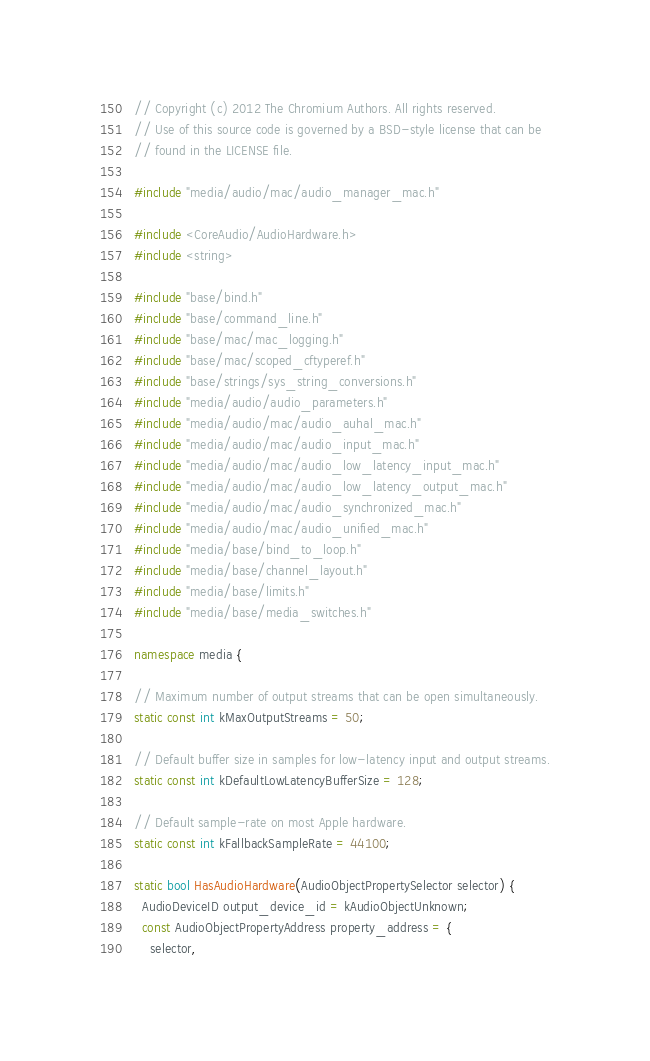Convert code to text. <code><loc_0><loc_0><loc_500><loc_500><_C++_>// Copyright (c) 2012 The Chromium Authors. All rights reserved.
// Use of this source code is governed by a BSD-style license that can be
// found in the LICENSE file.

#include "media/audio/mac/audio_manager_mac.h"

#include <CoreAudio/AudioHardware.h>
#include <string>

#include "base/bind.h"
#include "base/command_line.h"
#include "base/mac/mac_logging.h"
#include "base/mac/scoped_cftyperef.h"
#include "base/strings/sys_string_conversions.h"
#include "media/audio/audio_parameters.h"
#include "media/audio/mac/audio_auhal_mac.h"
#include "media/audio/mac/audio_input_mac.h"
#include "media/audio/mac/audio_low_latency_input_mac.h"
#include "media/audio/mac/audio_low_latency_output_mac.h"
#include "media/audio/mac/audio_synchronized_mac.h"
#include "media/audio/mac/audio_unified_mac.h"
#include "media/base/bind_to_loop.h"
#include "media/base/channel_layout.h"
#include "media/base/limits.h"
#include "media/base/media_switches.h"

namespace media {

// Maximum number of output streams that can be open simultaneously.
static const int kMaxOutputStreams = 50;

// Default buffer size in samples for low-latency input and output streams.
static const int kDefaultLowLatencyBufferSize = 128;

// Default sample-rate on most Apple hardware.
static const int kFallbackSampleRate = 44100;

static bool HasAudioHardware(AudioObjectPropertySelector selector) {
  AudioDeviceID output_device_id = kAudioObjectUnknown;
  const AudioObjectPropertyAddress property_address = {
    selector,</code> 